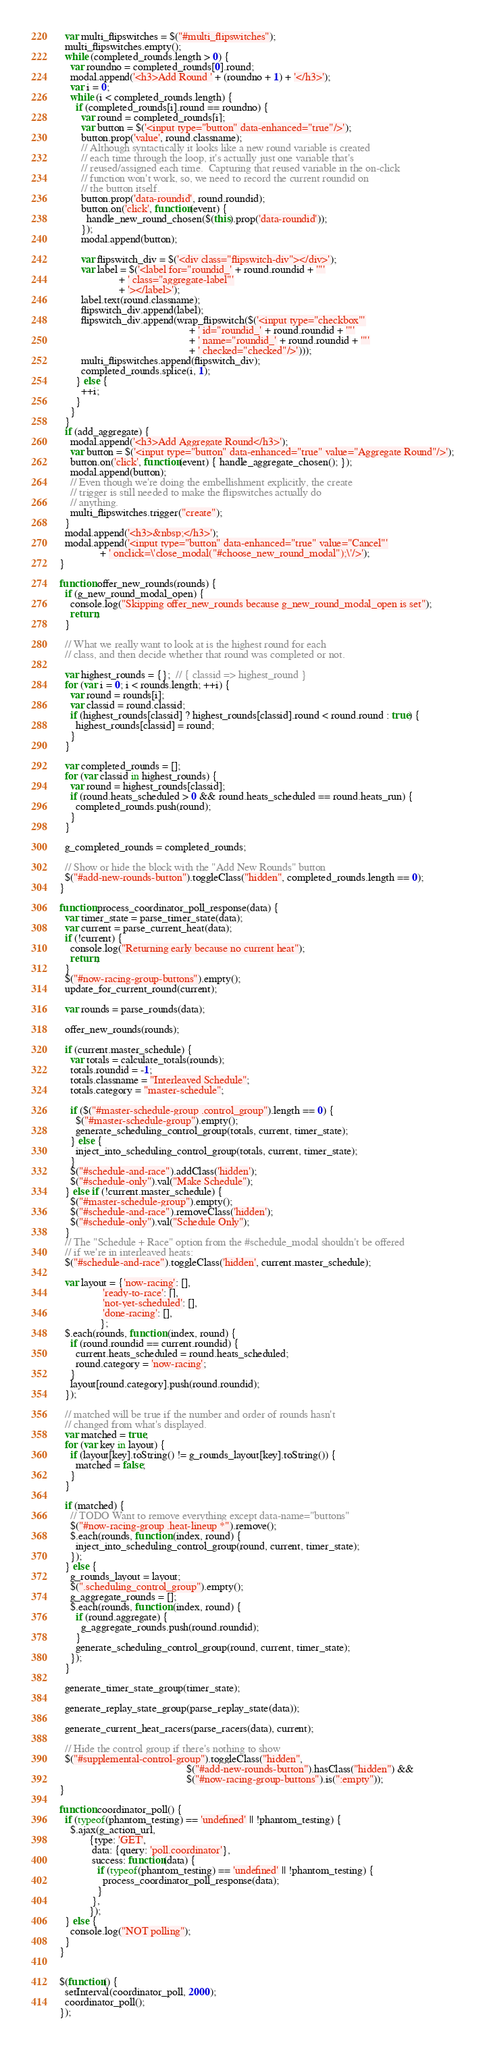<code> <loc_0><loc_0><loc_500><loc_500><_JavaScript_>  var multi_flipswitches = $("#multi_flipswitches");
  multi_flipswitches.empty();
  while (completed_rounds.length > 0) {
    var roundno = completed_rounds[0].round;
    modal.append('<h3>Add Round ' + (roundno + 1) + '</h3>');
    var i = 0;
    while (i < completed_rounds.length) {
      if (completed_rounds[i].round == roundno) {
        var round = completed_rounds[i];
        var button = $('<input type="button" data-enhanced="true"/>');
        button.prop('value', round.classname);
        // Although syntactically it looks like a new round variable is created
        // each time through the loop, it's actually just one variable that's
        // reused/assigned each time.  Capturing that reused variable in the on-click
        // function won't work, so, we need to record the current roundid on
        // the button itself.
        button.prop('data-roundid', round.roundid);
        button.on('click', function(event) {
          handle_new_round_chosen($(this).prop('data-roundid'));
        });
        modal.append(button);

        var flipswitch_div = $('<div class="flipswitch-div"></div>');
        var label = $('<label for="roundid_' + round.roundid + '"'
                      + ' class="aggregate-label"'
                      + '></label>');
        label.text(round.classname);
        flipswitch_div.append(label);
        flipswitch_div.append(wrap_flipswitch($('<input type="checkbox"'
                                                + ' id="roundid_' + round.roundid + '"'
                                                + ' name="roundid_' + round.roundid + '"'
                                                + ' checked="checked"/>')));
        multi_flipswitches.append(flipswitch_div);
        completed_rounds.splice(i, 1);
      } else {
        ++i;
      }
    }
  }
  if (add_aggregate) {
    modal.append('<h3>Add Aggregate Round</h3>');
    var button = $('<input type="button" data-enhanced="true" value="Aggregate Round"/>');
    button.on('click', function(event) { handle_aggregate_chosen(); });
    modal.append(button);
    // Even though we're doing the embellishment explicitly, the create
    // trigger is still needed to make the flipswitches actually do
    // anything.
    multi_flipswitches.trigger("create");
  }
  modal.append('<h3>&nbsp;</h3>');
  modal.append('<input type="button" data-enhanced="true" value="Cancel"'
               + ' onclick=\'close_modal("#choose_new_round_modal");\'/>');
}

function offer_new_rounds(rounds) {
  if (g_new_round_modal_open) {
    console.log("Skipping offer_new_rounds because g_new_round_modal_open is set");
    return;
  }

  // What we really want to look at is the highest round for each
  // class, and then decide whether that round was completed or not.

  var highest_rounds = {};  // { classid => highest_round }
  for (var i = 0; i < rounds.length; ++i) {
    var round = rounds[i];
    var classid = round.classid;
    if (highest_rounds[classid] ? highest_rounds[classid].round < round.round : true) {
      highest_rounds[classid] = round;
    }
  }

  var completed_rounds = [];
  for (var classid in highest_rounds) {
    var round = highest_rounds[classid];
    if (round.heats_scheduled > 0 && round.heats_scheduled == round.heats_run) {
      completed_rounds.push(round);
    }
  }

  g_completed_rounds = completed_rounds;

  // Show or hide the block with the "Add New Rounds" button
  $("#add-new-rounds-button").toggleClass("hidden", completed_rounds.length == 0);
}

function process_coordinator_poll_response(data) {
  var timer_state = parse_timer_state(data);
  var current = parse_current_heat(data);
  if (!current) {
    console.log("Returning early because no current heat");
    return;
  }
  $("#now-racing-group-buttons").empty();
  update_for_current_round(current);

  var rounds = parse_rounds(data);

  offer_new_rounds(rounds);

  if (current.master_schedule) {
    var totals = calculate_totals(rounds);
    totals.roundid = -1;
    totals.classname = "Interleaved Schedule";
    totals.category = "master-schedule";

    if ($("#master-schedule-group .control_group").length == 0) {
      $("#master-schedule-group").empty();
      generate_scheduling_control_group(totals, current, timer_state);
    } else {
      inject_into_scheduling_control_group(totals, current, timer_state);
    }
    $("#schedule-and-race").addClass('hidden');
    $("#schedule-only").val("Make Schedule");
  } else if (!current.master_schedule) {
    $("#master-schedule-group").empty();
    $("#schedule-and-race").removeClass('hidden');
    $("#schedule-only").val("Schedule Only");
  }
  // The "Schedule + Race" option from the #schedule_modal shouldn't be offered
  // if we're in interleaved heats:
  $("#schedule-and-race").toggleClass('hidden', current.master_schedule);

  var layout = {'now-racing': [],
                'ready-to-race': [],
                'not-yet-scheduled': [],
                'done-racing': [],
               };
  $.each(rounds, function (index, round) {
    if (round.roundid == current.roundid) {
      current.heats_scheduled = round.heats_scheduled;
      round.category = 'now-racing';
    }
    layout[round.category].push(round.roundid);
  });

  // matched will be true if the number and order of rounds hasn't
  // changed from what's displayed.
  var matched = true;
  for (var key in layout) {
    if (layout[key].toString() != g_rounds_layout[key].toString()) {
      matched = false;
    }
  }

  if (matched) {
    // TODO Want to remove everything except data-name="buttons"
    $("#now-racing-group .heat-lineup *").remove();
    $.each(rounds, function (index, round) {
      inject_into_scheduling_control_group(round, current, timer_state);
    });
  } else {
    g_rounds_layout = layout;
    $(".scheduling_control_group").empty();
    g_aggregate_rounds = [];
    $.each(rounds, function (index, round) {
      if (round.aggregate) {
        g_aggregate_rounds.push(round.roundid);
      }
      generate_scheduling_control_group(round, current, timer_state);
    });
  }

  generate_timer_state_group(timer_state);

  generate_replay_state_group(parse_replay_state(data));

  generate_current_heat_racers(parse_racers(data), current);

  // Hide the control group if there's nothing to show
  $("#supplemental-control-group").toggleClass("hidden",
                                               $("#add-new-rounds-button").hasClass("hidden") &&
                                               $("#now-racing-group-buttons").is(":empty"));
}

function coordinator_poll() {
  if (typeof(phantom_testing) == 'undefined' || !phantom_testing) {
    $.ajax(g_action_url,
           {type: 'GET',
            data: {query: 'poll.coordinator'},
            success: function(data) {
              if (typeof(phantom_testing) == 'undefined' || !phantom_testing) {
                process_coordinator_poll_response(data);
              }
            },
           });
  } else {
    console.log("NOT polling");
  }
}


$(function() {
  setInterval(coordinator_poll, 2000);
  coordinator_poll();
});
</code> 